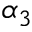Convert formula to latex. <formula><loc_0><loc_0><loc_500><loc_500>\alpha _ { 3 }</formula> 